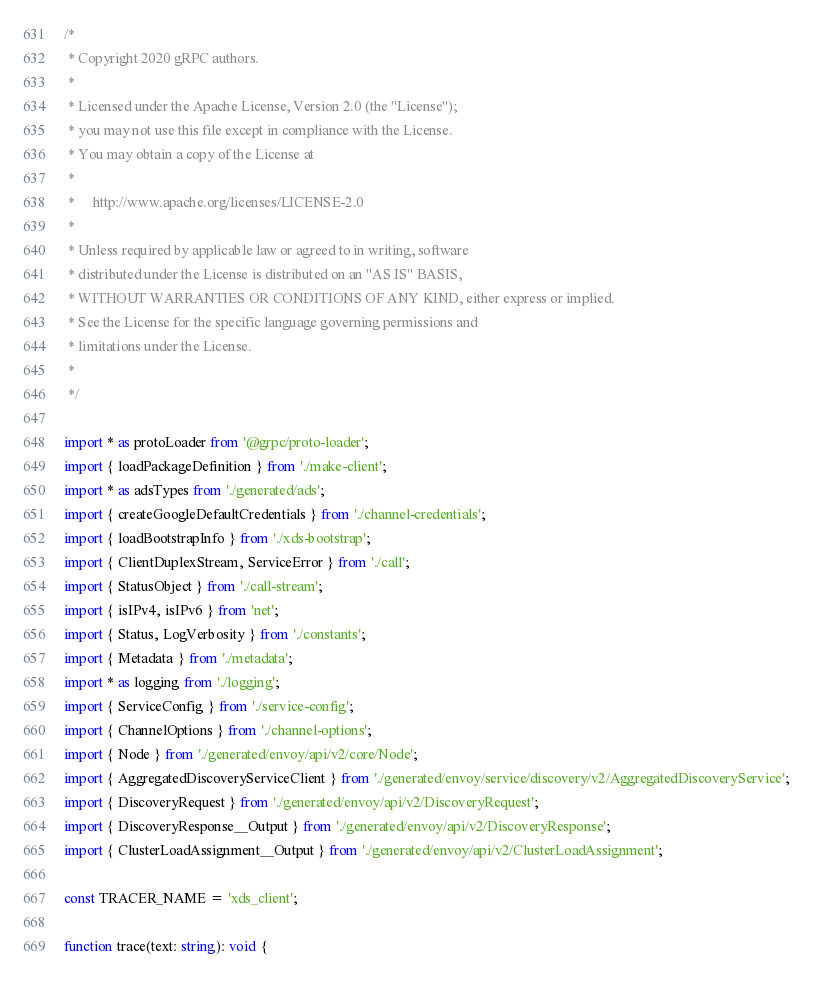Convert code to text. <code><loc_0><loc_0><loc_500><loc_500><_TypeScript_>/*
 * Copyright 2020 gRPC authors.
 *
 * Licensed under the Apache License, Version 2.0 (the "License");
 * you may not use this file except in compliance with the License.
 * You may obtain a copy of the License at
 *
 *     http://www.apache.org/licenses/LICENSE-2.0
 *
 * Unless required by applicable law or agreed to in writing, software
 * distributed under the License is distributed on an "AS IS" BASIS,
 * WITHOUT WARRANTIES OR CONDITIONS OF ANY KIND, either express or implied.
 * See the License for the specific language governing permissions and
 * limitations under the License.
 *
 */

import * as protoLoader from '@grpc/proto-loader';
import { loadPackageDefinition } from './make-client';
import * as adsTypes from './generated/ads';
import { createGoogleDefaultCredentials } from './channel-credentials';
import { loadBootstrapInfo } from './xds-bootstrap';
import { ClientDuplexStream, ServiceError } from './call';
import { StatusObject } from './call-stream';
import { isIPv4, isIPv6 } from 'net';
import { Status, LogVerbosity } from './constants';
import { Metadata } from './metadata';
import * as logging from './logging';
import { ServiceConfig } from './service-config';
import { ChannelOptions } from './channel-options';
import { Node } from './generated/envoy/api/v2/core/Node';
import { AggregatedDiscoveryServiceClient } from './generated/envoy/service/discovery/v2/AggregatedDiscoveryService';
import { DiscoveryRequest } from './generated/envoy/api/v2/DiscoveryRequest';
import { DiscoveryResponse__Output } from './generated/envoy/api/v2/DiscoveryResponse';
import { ClusterLoadAssignment__Output } from './generated/envoy/api/v2/ClusterLoadAssignment';

const TRACER_NAME = 'xds_client';

function trace(text: string): void {</code> 